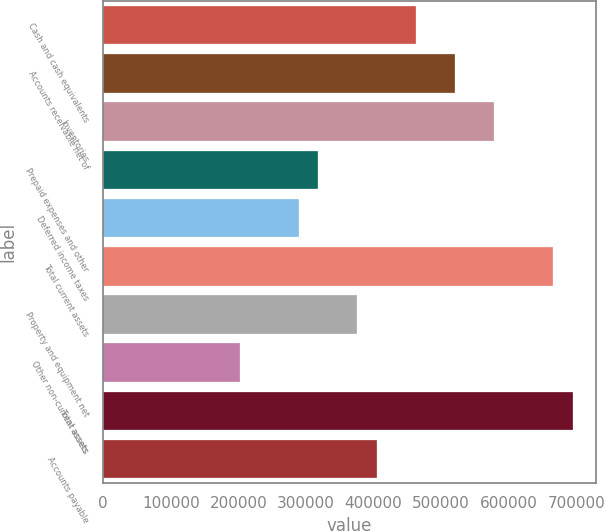Convert chart to OTSL. <chart><loc_0><loc_0><loc_500><loc_500><bar_chart><fcel>Cash and cash equivalents<fcel>Accounts receivable net of<fcel>Inventories<fcel>Prepaid expenses and other<fcel>Deferred income taxes<fcel>Total current assets<fcel>Property and equipment net<fcel>Other non-current assets<fcel>Total assets<fcel>Accounts payable<nl><fcel>462986<fcel>520859<fcel>578732<fcel>318304<fcel>289368<fcel>665541<fcel>376177<fcel>202559<fcel>694478<fcel>405114<nl></chart> 